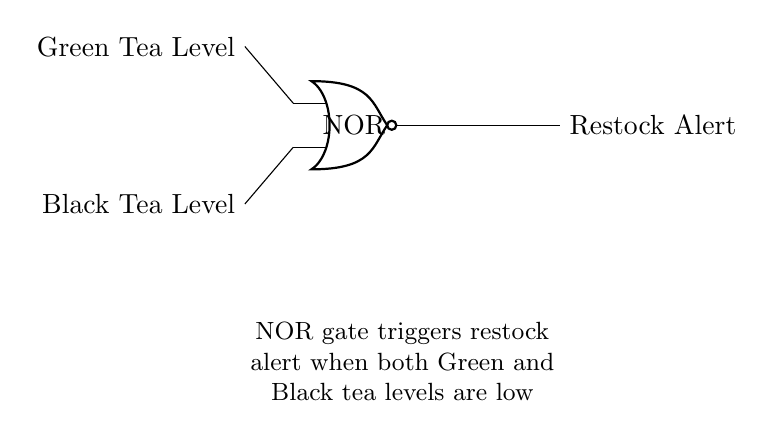What is the output of the NOR gate when both inputs are high? The output of a NOR gate is low when any of its inputs are high. Here, both Green Tea Level and Black Tea Level have to be low for the output, which is a restock alert, to be high.
Answer: low What are the two inputs to the NOR gate? The circuit shows that the inputs to the NOR gate are the levels of Green Tea and Black Tea. They are labeled explicitly on the left side.
Answer: Green Tea Level and Black Tea Level When does the restock alert trigger? A NOR gate triggers its output when both inputs are low. In this case, the restock alert will trigger when both the Green Tea Level and the Black Tea Level are low, indicating that restocking is needed.
Answer: Both inputs are low What is the function of the NOR gate in this circuit? The NOR gate functions to combine the input signals (Green Tea and Black Tea levels) and determine the restock alert output. When both inputs are low, it activates the alert, indicating a need for restocking.
Answer: Determine restock alert What is the significance of the labels on the inputs? The labels on the inputs are significant as they denote which tea levels are being monitored. They provide clarity on what the NOR gate is processing, ensuring that the circuit's purpose is understood.
Answer: Monitoring tea levels Which logic gate is used in this circuit? The circuit diagram clearly indicates that a NOR gate is used, as depicted by its symbol and labeling. This type of logic gate processes the input signals accordingly to produce an output.
Answer: NOR gate 